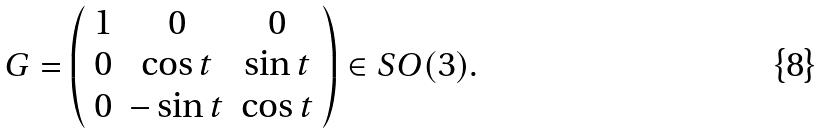<formula> <loc_0><loc_0><loc_500><loc_500>G = \left ( \begin{array} { c c c } 1 & 0 & 0 \\ 0 & \cos t & \sin t \\ 0 & - \sin t & \cos t \end{array} \right ) \in S O ( 3 ) .</formula> 